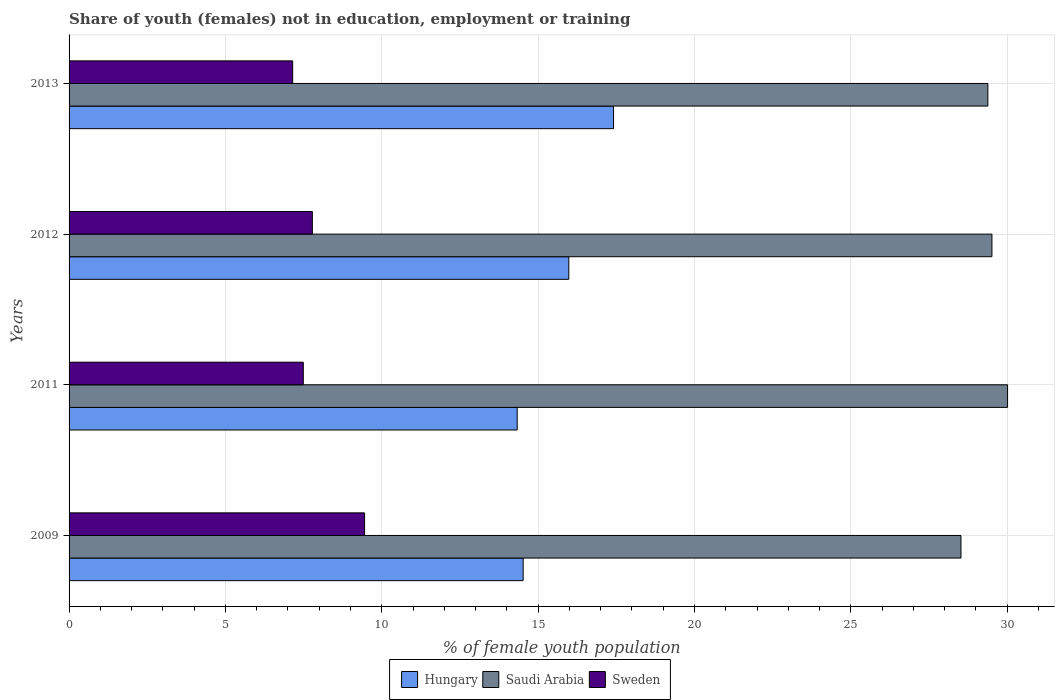How many groups of bars are there?
Your answer should be very brief. 4. How many bars are there on the 4th tick from the bottom?
Offer a very short reply. 3. In how many cases, is the number of bars for a given year not equal to the number of legend labels?
Provide a short and direct response. 0. What is the percentage of unemployed female population in in Saudi Arabia in 2012?
Provide a succinct answer. 29.51. Across all years, what is the maximum percentage of unemployed female population in in Sweden?
Provide a succinct answer. 9.45. Across all years, what is the minimum percentage of unemployed female population in in Saudi Arabia?
Keep it short and to the point. 28.52. What is the total percentage of unemployed female population in in Saudi Arabia in the graph?
Provide a succinct answer. 117.42. What is the difference between the percentage of unemployed female population in in Saudi Arabia in 2011 and that in 2012?
Ensure brevity in your answer.  0.5. What is the difference between the percentage of unemployed female population in in Sweden in 2009 and the percentage of unemployed female population in in Saudi Arabia in 2012?
Your response must be concise. -20.06. What is the average percentage of unemployed female population in in Saudi Arabia per year?
Provide a short and direct response. 29.36. In the year 2011, what is the difference between the percentage of unemployed female population in in Hungary and percentage of unemployed female population in in Sweden?
Offer a very short reply. 6.84. In how many years, is the percentage of unemployed female population in in Hungary greater than 23 %?
Keep it short and to the point. 0. What is the ratio of the percentage of unemployed female population in in Sweden in 2009 to that in 2011?
Provide a succinct answer. 1.26. Is the percentage of unemployed female population in in Hungary in 2012 less than that in 2013?
Give a very brief answer. Yes. Is the difference between the percentage of unemployed female population in in Hungary in 2011 and 2013 greater than the difference between the percentage of unemployed female population in in Sweden in 2011 and 2013?
Offer a very short reply. No. What is the difference between the highest and the second highest percentage of unemployed female population in in Sweden?
Give a very brief answer. 1.67. What is the difference between the highest and the lowest percentage of unemployed female population in in Saudi Arabia?
Your response must be concise. 1.49. In how many years, is the percentage of unemployed female population in in Saudi Arabia greater than the average percentage of unemployed female population in in Saudi Arabia taken over all years?
Offer a terse response. 3. Is the sum of the percentage of unemployed female population in in Saudi Arabia in 2011 and 2012 greater than the maximum percentage of unemployed female population in in Sweden across all years?
Keep it short and to the point. Yes. What does the 3rd bar from the bottom in 2009 represents?
Your answer should be very brief. Sweden. How many bars are there?
Provide a short and direct response. 12. Are all the bars in the graph horizontal?
Offer a very short reply. Yes. Does the graph contain grids?
Your response must be concise. Yes. What is the title of the graph?
Offer a terse response. Share of youth (females) not in education, employment or training. What is the label or title of the X-axis?
Provide a short and direct response. % of female youth population. What is the % of female youth population in Hungary in 2009?
Your response must be concise. 14.52. What is the % of female youth population of Saudi Arabia in 2009?
Provide a succinct answer. 28.52. What is the % of female youth population in Sweden in 2009?
Your answer should be compact. 9.45. What is the % of female youth population in Hungary in 2011?
Your response must be concise. 14.33. What is the % of female youth population in Saudi Arabia in 2011?
Provide a short and direct response. 30.01. What is the % of female youth population in Sweden in 2011?
Your answer should be very brief. 7.49. What is the % of female youth population in Hungary in 2012?
Give a very brief answer. 15.98. What is the % of female youth population of Saudi Arabia in 2012?
Give a very brief answer. 29.51. What is the % of female youth population in Sweden in 2012?
Provide a succinct answer. 7.78. What is the % of female youth population in Hungary in 2013?
Your response must be concise. 17.41. What is the % of female youth population in Saudi Arabia in 2013?
Provide a succinct answer. 29.38. What is the % of female youth population of Sweden in 2013?
Provide a succinct answer. 7.15. Across all years, what is the maximum % of female youth population in Hungary?
Your answer should be compact. 17.41. Across all years, what is the maximum % of female youth population of Saudi Arabia?
Make the answer very short. 30.01. Across all years, what is the maximum % of female youth population of Sweden?
Make the answer very short. 9.45. Across all years, what is the minimum % of female youth population in Hungary?
Give a very brief answer. 14.33. Across all years, what is the minimum % of female youth population in Saudi Arabia?
Ensure brevity in your answer.  28.52. Across all years, what is the minimum % of female youth population in Sweden?
Offer a terse response. 7.15. What is the total % of female youth population of Hungary in the graph?
Your answer should be very brief. 62.24. What is the total % of female youth population of Saudi Arabia in the graph?
Your answer should be compact. 117.42. What is the total % of female youth population of Sweden in the graph?
Ensure brevity in your answer.  31.87. What is the difference between the % of female youth population of Hungary in 2009 and that in 2011?
Make the answer very short. 0.19. What is the difference between the % of female youth population of Saudi Arabia in 2009 and that in 2011?
Offer a very short reply. -1.49. What is the difference between the % of female youth population in Sweden in 2009 and that in 2011?
Your answer should be compact. 1.96. What is the difference between the % of female youth population in Hungary in 2009 and that in 2012?
Give a very brief answer. -1.46. What is the difference between the % of female youth population of Saudi Arabia in 2009 and that in 2012?
Your response must be concise. -0.99. What is the difference between the % of female youth population of Sweden in 2009 and that in 2012?
Make the answer very short. 1.67. What is the difference between the % of female youth population in Hungary in 2009 and that in 2013?
Give a very brief answer. -2.89. What is the difference between the % of female youth population of Saudi Arabia in 2009 and that in 2013?
Ensure brevity in your answer.  -0.86. What is the difference between the % of female youth population in Sweden in 2009 and that in 2013?
Your answer should be very brief. 2.3. What is the difference between the % of female youth population of Hungary in 2011 and that in 2012?
Ensure brevity in your answer.  -1.65. What is the difference between the % of female youth population in Saudi Arabia in 2011 and that in 2012?
Ensure brevity in your answer.  0.5. What is the difference between the % of female youth population of Sweden in 2011 and that in 2012?
Give a very brief answer. -0.29. What is the difference between the % of female youth population of Hungary in 2011 and that in 2013?
Your response must be concise. -3.08. What is the difference between the % of female youth population of Saudi Arabia in 2011 and that in 2013?
Your answer should be compact. 0.63. What is the difference between the % of female youth population of Sweden in 2011 and that in 2013?
Provide a short and direct response. 0.34. What is the difference between the % of female youth population of Hungary in 2012 and that in 2013?
Keep it short and to the point. -1.43. What is the difference between the % of female youth population of Saudi Arabia in 2012 and that in 2013?
Ensure brevity in your answer.  0.13. What is the difference between the % of female youth population of Sweden in 2012 and that in 2013?
Make the answer very short. 0.63. What is the difference between the % of female youth population in Hungary in 2009 and the % of female youth population in Saudi Arabia in 2011?
Your response must be concise. -15.49. What is the difference between the % of female youth population in Hungary in 2009 and the % of female youth population in Sweden in 2011?
Give a very brief answer. 7.03. What is the difference between the % of female youth population in Saudi Arabia in 2009 and the % of female youth population in Sweden in 2011?
Your response must be concise. 21.03. What is the difference between the % of female youth population of Hungary in 2009 and the % of female youth population of Saudi Arabia in 2012?
Provide a short and direct response. -14.99. What is the difference between the % of female youth population of Hungary in 2009 and the % of female youth population of Sweden in 2012?
Ensure brevity in your answer.  6.74. What is the difference between the % of female youth population of Saudi Arabia in 2009 and the % of female youth population of Sweden in 2012?
Your answer should be very brief. 20.74. What is the difference between the % of female youth population in Hungary in 2009 and the % of female youth population in Saudi Arabia in 2013?
Give a very brief answer. -14.86. What is the difference between the % of female youth population in Hungary in 2009 and the % of female youth population in Sweden in 2013?
Your response must be concise. 7.37. What is the difference between the % of female youth population of Saudi Arabia in 2009 and the % of female youth population of Sweden in 2013?
Your answer should be compact. 21.37. What is the difference between the % of female youth population in Hungary in 2011 and the % of female youth population in Saudi Arabia in 2012?
Offer a very short reply. -15.18. What is the difference between the % of female youth population of Hungary in 2011 and the % of female youth population of Sweden in 2012?
Your response must be concise. 6.55. What is the difference between the % of female youth population of Saudi Arabia in 2011 and the % of female youth population of Sweden in 2012?
Offer a very short reply. 22.23. What is the difference between the % of female youth population of Hungary in 2011 and the % of female youth population of Saudi Arabia in 2013?
Ensure brevity in your answer.  -15.05. What is the difference between the % of female youth population of Hungary in 2011 and the % of female youth population of Sweden in 2013?
Your answer should be compact. 7.18. What is the difference between the % of female youth population in Saudi Arabia in 2011 and the % of female youth population in Sweden in 2013?
Give a very brief answer. 22.86. What is the difference between the % of female youth population of Hungary in 2012 and the % of female youth population of Sweden in 2013?
Your answer should be compact. 8.83. What is the difference between the % of female youth population in Saudi Arabia in 2012 and the % of female youth population in Sweden in 2013?
Offer a terse response. 22.36. What is the average % of female youth population in Hungary per year?
Provide a succinct answer. 15.56. What is the average % of female youth population of Saudi Arabia per year?
Offer a terse response. 29.36. What is the average % of female youth population of Sweden per year?
Offer a terse response. 7.97. In the year 2009, what is the difference between the % of female youth population of Hungary and % of female youth population of Saudi Arabia?
Keep it short and to the point. -14. In the year 2009, what is the difference between the % of female youth population of Hungary and % of female youth population of Sweden?
Your answer should be compact. 5.07. In the year 2009, what is the difference between the % of female youth population in Saudi Arabia and % of female youth population in Sweden?
Ensure brevity in your answer.  19.07. In the year 2011, what is the difference between the % of female youth population of Hungary and % of female youth population of Saudi Arabia?
Make the answer very short. -15.68. In the year 2011, what is the difference between the % of female youth population of Hungary and % of female youth population of Sweden?
Make the answer very short. 6.84. In the year 2011, what is the difference between the % of female youth population of Saudi Arabia and % of female youth population of Sweden?
Keep it short and to the point. 22.52. In the year 2012, what is the difference between the % of female youth population of Hungary and % of female youth population of Saudi Arabia?
Provide a short and direct response. -13.53. In the year 2012, what is the difference between the % of female youth population of Hungary and % of female youth population of Sweden?
Make the answer very short. 8.2. In the year 2012, what is the difference between the % of female youth population of Saudi Arabia and % of female youth population of Sweden?
Ensure brevity in your answer.  21.73. In the year 2013, what is the difference between the % of female youth population in Hungary and % of female youth population in Saudi Arabia?
Your answer should be compact. -11.97. In the year 2013, what is the difference between the % of female youth population in Hungary and % of female youth population in Sweden?
Offer a terse response. 10.26. In the year 2013, what is the difference between the % of female youth population of Saudi Arabia and % of female youth population of Sweden?
Keep it short and to the point. 22.23. What is the ratio of the % of female youth population in Hungary in 2009 to that in 2011?
Provide a short and direct response. 1.01. What is the ratio of the % of female youth population of Saudi Arabia in 2009 to that in 2011?
Offer a terse response. 0.95. What is the ratio of the % of female youth population of Sweden in 2009 to that in 2011?
Your answer should be compact. 1.26. What is the ratio of the % of female youth population in Hungary in 2009 to that in 2012?
Your answer should be compact. 0.91. What is the ratio of the % of female youth population in Saudi Arabia in 2009 to that in 2012?
Ensure brevity in your answer.  0.97. What is the ratio of the % of female youth population in Sweden in 2009 to that in 2012?
Your answer should be very brief. 1.21. What is the ratio of the % of female youth population in Hungary in 2009 to that in 2013?
Your response must be concise. 0.83. What is the ratio of the % of female youth population in Saudi Arabia in 2009 to that in 2013?
Make the answer very short. 0.97. What is the ratio of the % of female youth population in Sweden in 2009 to that in 2013?
Ensure brevity in your answer.  1.32. What is the ratio of the % of female youth population in Hungary in 2011 to that in 2012?
Provide a succinct answer. 0.9. What is the ratio of the % of female youth population in Saudi Arabia in 2011 to that in 2012?
Keep it short and to the point. 1.02. What is the ratio of the % of female youth population in Sweden in 2011 to that in 2012?
Your answer should be very brief. 0.96. What is the ratio of the % of female youth population in Hungary in 2011 to that in 2013?
Provide a succinct answer. 0.82. What is the ratio of the % of female youth population of Saudi Arabia in 2011 to that in 2013?
Give a very brief answer. 1.02. What is the ratio of the % of female youth population of Sweden in 2011 to that in 2013?
Give a very brief answer. 1.05. What is the ratio of the % of female youth population of Hungary in 2012 to that in 2013?
Keep it short and to the point. 0.92. What is the ratio of the % of female youth population of Sweden in 2012 to that in 2013?
Offer a terse response. 1.09. What is the difference between the highest and the second highest % of female youth population in Hungary?
Make the answer very short. 1.43. What is the difference between the highest and the second highest % of female youth population in Saudi Arabia?
Give a very brief answer. 0.5. What is the difference between the highest and the second highest % of female youth population in Sweden?
Ensure brevity in your answer.  1.67. What is the difference between the highest and the lowest % of female youth population in Hungary?
Keep it short and to the point. 3.08. What is the difference between the highest and the lowest % of female youth population of Saudi Arabia?
Offer a terse response. 1.49. 